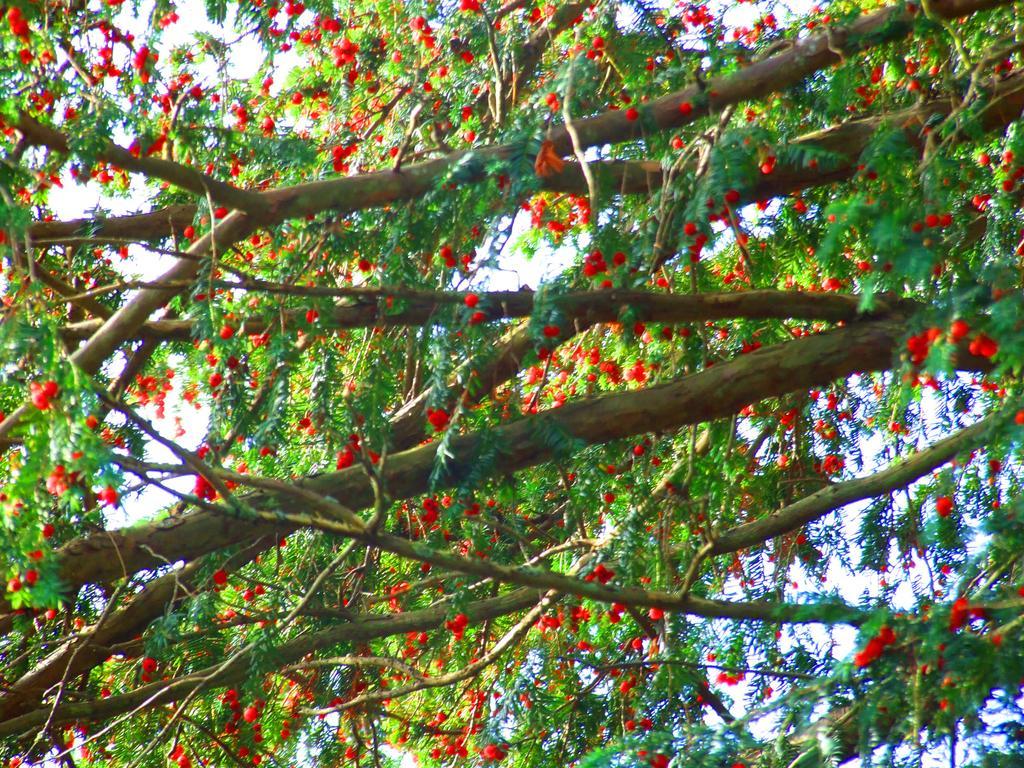Could you give a brief overview of what you see in this image? In the foreground of the image, there are flowers to the trees. In the background, there is the sky. 